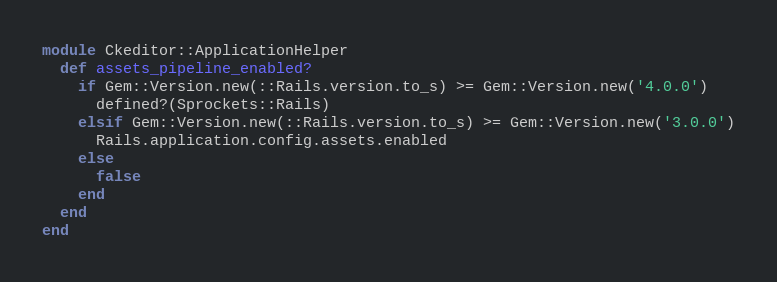Convert code to text. <code><loc_0><loc_0><loc_500><loc_500><_Ruby_>module Ckeditor::ApplicationHelper
  def assets_pipeline_enabled?
    if Gem::Version.new(::Rails.version.to_s) >= Gem::Version.new('4.0.0')
      defined?(Sprockets::Rails)
    elsif Gem::Version.new(::Rails.version.to_s) >= Gem::Version.new('3.0.0')
      Rails.application.config.assets.enabled
    else
      false
    end
  end
end</code> 